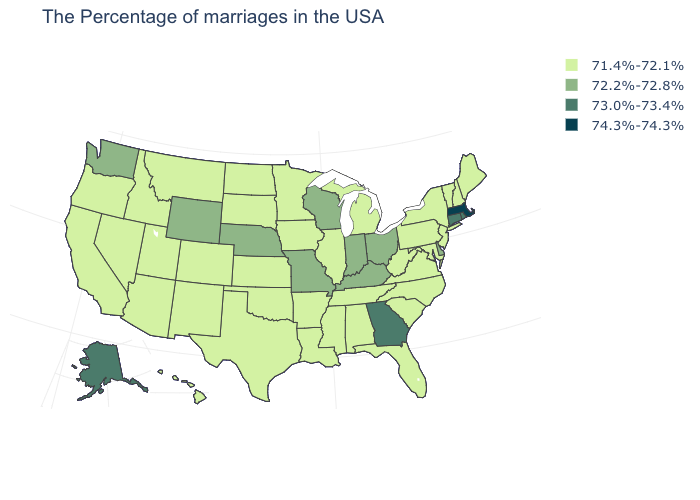Does Ohio have the highest value in the MidWest?
Short answer required. Yes. Does the first symbol in the legend represent the smallest category?
Concise answer only. Yes. What is the highest value in the USA?
Keep it brief. 74.3%-74.3%. Among the states that border Connecticut , which have the lowest value?
Write a very short answer. New York. What is the value of Oregon?
Be succinct. 71.4%-72.1%. What is the value of New Jersey?
Keep it brief. 71.4%-72.1%. Does Florida have the highest value in the USA?
Answer briefly. No. Which states hav the highest value in the Northeast?
Short answer required. Massachusetts. Is the legend a continuous bar?
Answer briefly. No. What is the lowest value in states that border Wisconsin?
Keep it brief. 71.4%-72.1%. What is the highest value in states that border Colorado?
Give a very brief answer. 72.2%-72.8%. Name the states that have a value in the range 71.4%-72.1%?
Write a very short answer. Maine, New Hampshire, Vermont, New York, New Jersey, Maryland, Pennsylvania, Virginia, North Carolina, South Carolina, West Virginia, Florida, Michigan, Alabama, Tennessee, Illinois, Mississippi, Louisiana, Arkansas, Minnesota, Iowa, Kansas, Oklahoma, Texas, South Dakota, North Dakota, Colorado, New Mexico, Utah, Montana, Arizona, Idaho, Nevada, California, Oregon, Hawaii. Name the states that have a value in the range 71.4%-72.1%?
Concise answer only. Maine, New Hampshire, Vermont, New York, New Jersey, Maryland, Pennsylvania, Virginia, North Carolina, South Carolina, West Virginia, Florida, Michigan, Alabama, Tennessee, Illinois, Mississippi, Louisiana, Arkansas, Minnesota, Iowa, Kansas, Oklahoma, Texas, South Dakota, North Dakota, Colorado, New Mexico, Utah, Montana, Arizona, Idaho, Nevada, California, Oregon, Hawaii. What is the value of Nebraska?
Keep it brief. 72.2%-72.8%. 